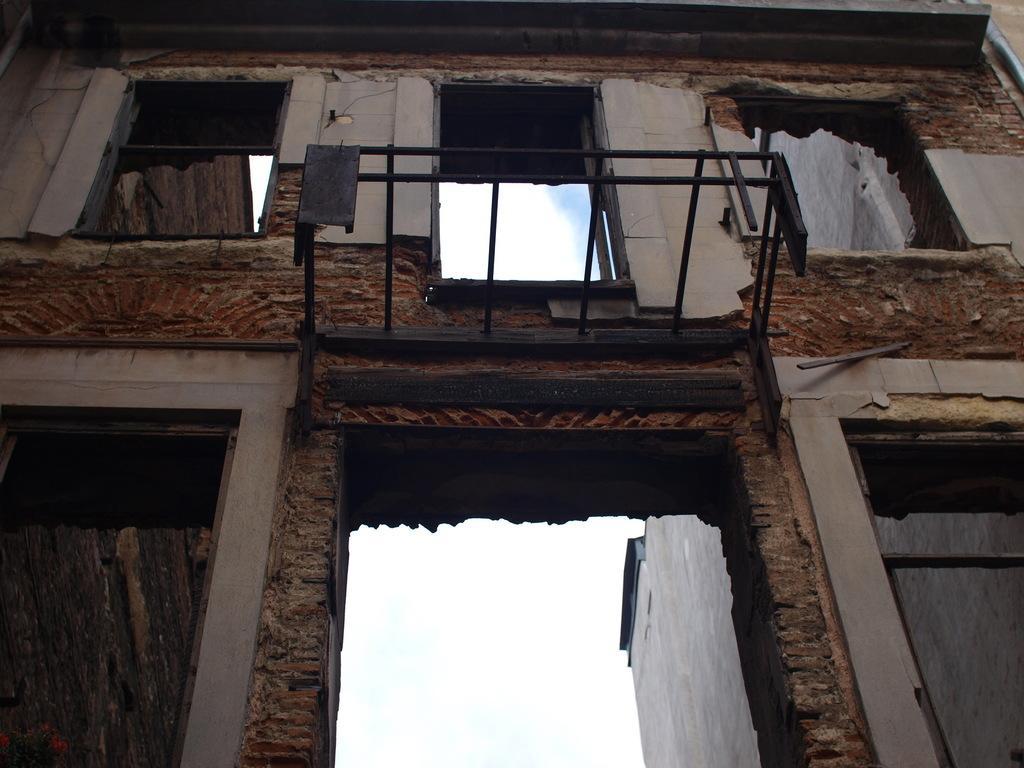Describe this image in one or two sentences. This picture is taken in the lower angle where I can see the building, the wall and I can see the sky in the background. 